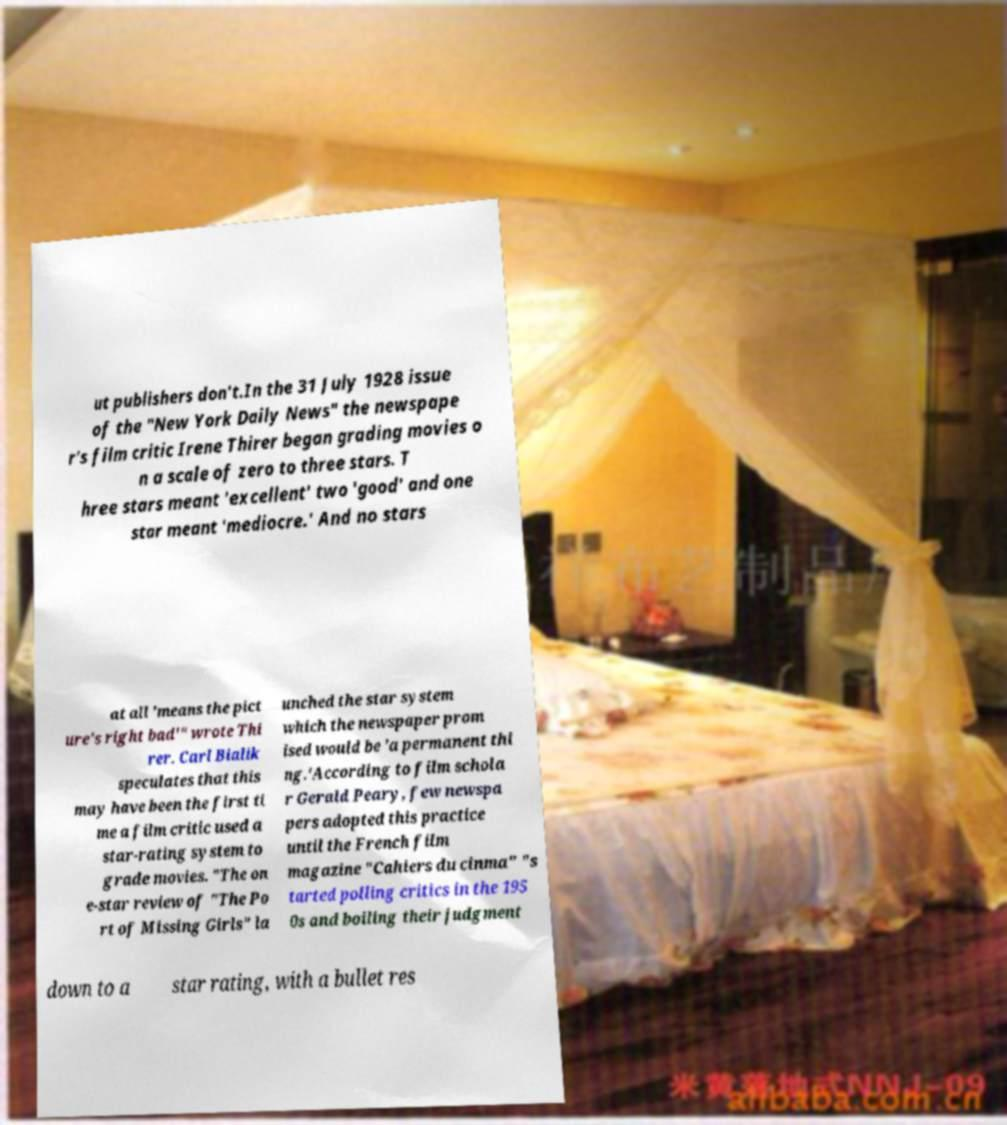Can you read and provide the text displayed in the image?This photo seems to have some interesting text. Can you extract and type it out for me? ut publishers don't.In the 31 July 1928 issue of the "New York Daily News" the newspape r's film critic Irene Thirer began grading movies o n a scale of zero to three stars. T hree stars meant 'excellent' two 'good' and one star meant 'mediocre.' And no stars at all 'means the pict ure's right bad'" wrote Thi rer. Carl Bialik speculates that this may have been the first ti me a film critic used a star-rating system to grade movies. "The on e-star review of "The Po rt of Missing Girls" la unched the star system which the newspaper prom ised would be 'a permanent thi ng.'According to film schola r Gerald Peary, few newspa pers adopted this practice until the French film magazine "Cahiers du cinma" "s tarted polling critics in the 195 0s and boiling their judgment down to a star rating, with a bullet res 